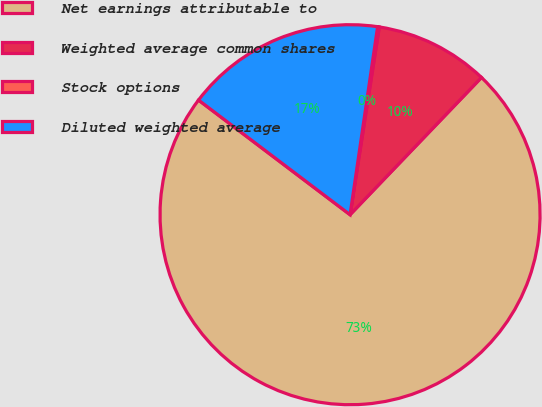Convert chart to OTSL. <chart><loc_0><loc_0><loc_500><loc_500><pie_chart><fcel>Net earnings attributable to<fcel>Weighted average common shares<fcel>Stock options<fcel>Diluted weighted average<nl><fcel>73.15%<fcel>9.7%<fcel>0.14%<fcel>17.01%<nl></chart> 